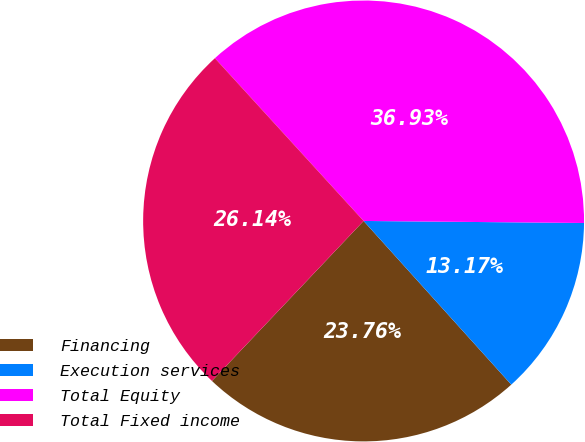Convert chart. <chart><loc_0><loc_0><loc_500><loc_500><pie_chart><fcel>Financing<fcel>Execution services<fcel>Total Equity<fcel>Total Fixed income<nl><fcel>23.76%<fcel>13.17%<fcel>36.93%<fcel>26.14%<nl></chart> 